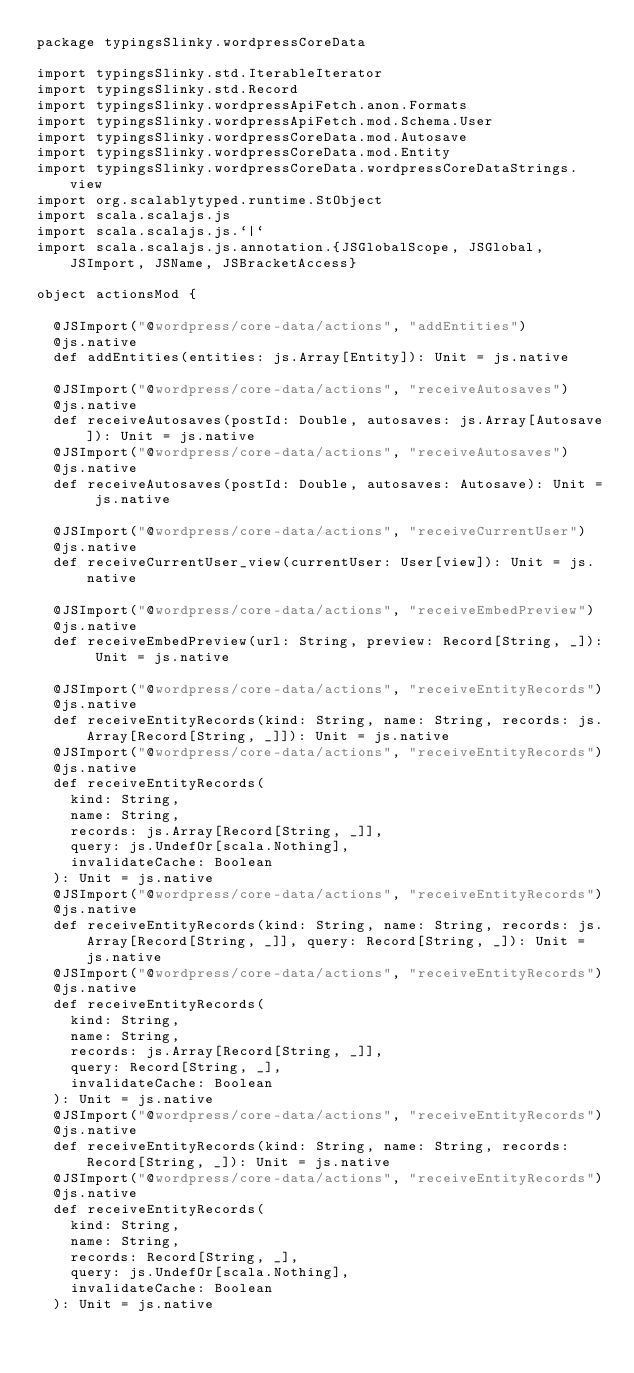Convert code to text. <code><loc_0><loc_0><loc_500><loc_500><_Scala_>package typingsSlinky.wordpressCoreData

import typingsSlinky.std.IterableIterator
import typingsSlinky.std.Record
import typingsSlinky.wordpressApiFetch.anon.Formats
import typingsSlinky.wordpressApiFetch.mod.Schema.User
import typingsSlinky.wordpressCoreData.mod.Autosave
import typingsSlinky.wordpressCoreData.mod.Entity
import typingsSlinky.wordpressCoreData.wordpressCoreDataStrings.view
import org.scalablytyped.runtime.StObject
import scala.scalajs.js
import scala.scalajs.js.`|`
import scala.scalajs.js.annotation.{JSGlobalScope, JSGlobal, JSImport, JSName, JSBracketAccess}

object actionsMod {
  
  @JSImport("@wordpress/core-data/actions", "addEntities")
  @js.native
  def addEntities(entities: js.Array[Entity]): Unit = js.native
  
  @JSImport("@wordpress/core-data/actions", "receiveAutosaves")
  @js.native
  def receiveAutosaves(postId: Double, autosaves: js.Array[Autosave]): Unit = js.native
  @JSImport("@wordpress/core-data/actions", "receiveAutosaves")
  @js.native
  def receiveAutosaves(postId: Double, autosaves: Autosave): Unit = js.native
  
  @JSImport("@wordpress/core-data/actions", "receiveCurrentUser")
  @js.native
  def receiveCurrentUser_view(currentUser: User[view]): Unit = js.native
  
  @JSImport("@wordpress/core-data/actions", "receiveEmbedPreview")
  @js.native
  def receiveEmbedPreview(url: String, preview: Record[String, _]): Unit = js.native
  
  @JSImport("@wordpress/core-data/actions", "receiveEntityRecords")
  @js.native
  def receiveEntityRecords(kind: String, name: String, records: js.Array[Record[String, _]]): Unit = js.native
  @JSImport("@wordpress/core-data/actions", "receiveEntityRecords")
  @js.native
  def receiveEntityRecords(
    kind: String,
    name: String,
    records: js.Array[Record[String, _]],
    query: js.UndefOr[scala.Nothing],
    invalidateCache: Boolean
  ): Unit = js.native
  @JSImport("@wordpress/core-data/actions", "receiveEntityRecords")
  @js.native
  def receiveEntityRecords(kind: String, name: String, records: js.Array[Record[String, _]], query: Record[String, _]): Unit = js.native
  @JSImport("@wordpress/core-data/actions", "receiveEntityRecords")
  @js.native
  def receiveEntityRecords(
    kind: String,
    name: String,
    records: js.Array[Record[String, _]],
    query: Record[String, _],
    invalidateCache: Boolean
  ): Unit = js.native
  @JSImport("@wordpress/core-data/actions", "receiveEntityRecords")
  @js.native
  def receiveEntityRecords(kind: String, name: String, records: Record[String, _]): Unit = js.native
  @JSImport("@wordpress/core-data/actions", "receiveEntityRecords")
  @js.native
  def receiveEntityRecords(
    kind: String,
    name: String,
    records: Record[String, _],
    query: js.UndefOr[scala.Nothing],
    invalidateCache: Boolean
  ): Unit = js.native</code> 